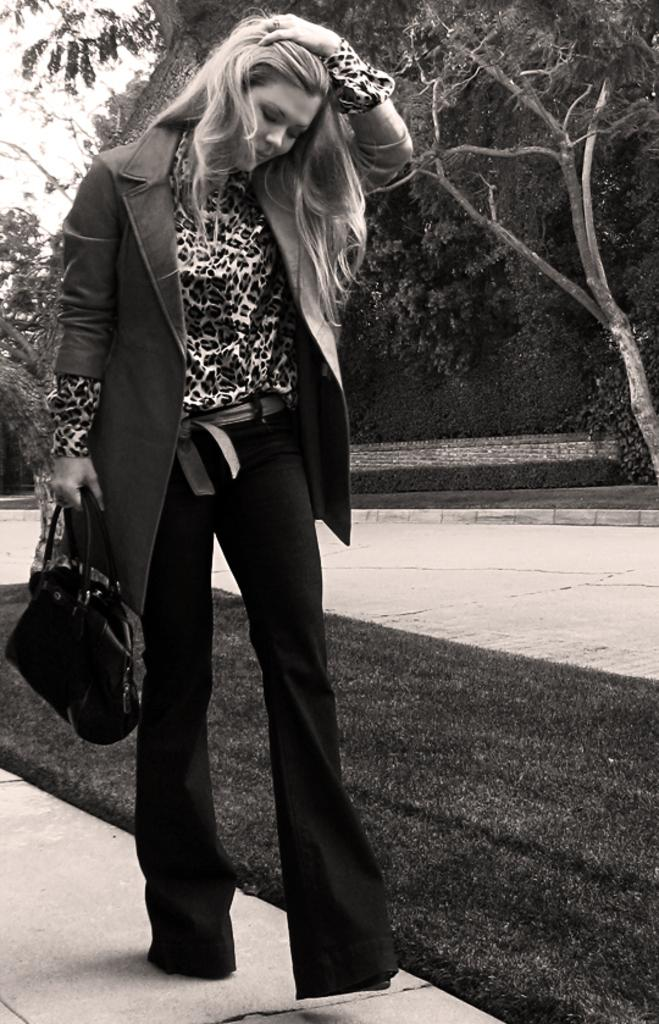Who is present in the image? There is a woman in the image. What is the woman wearing on her upper body? The woman is wearing a coat. What type of pants is the woman wearing? The woman is wearing black pants. What is the woman holding in her hand? The woman is holding a bag in her hand. What action is the woman performing in the image? The woman is adjusting her hair. What can be seen in the background of the image? There are trees and the sky visible in the background of the image. What type of shirt is the woman reading in the image? There is no shirt or reading activity present in the image. The woman is wearing a coat and adjusting her hair, and there is no indication of any reading material. 